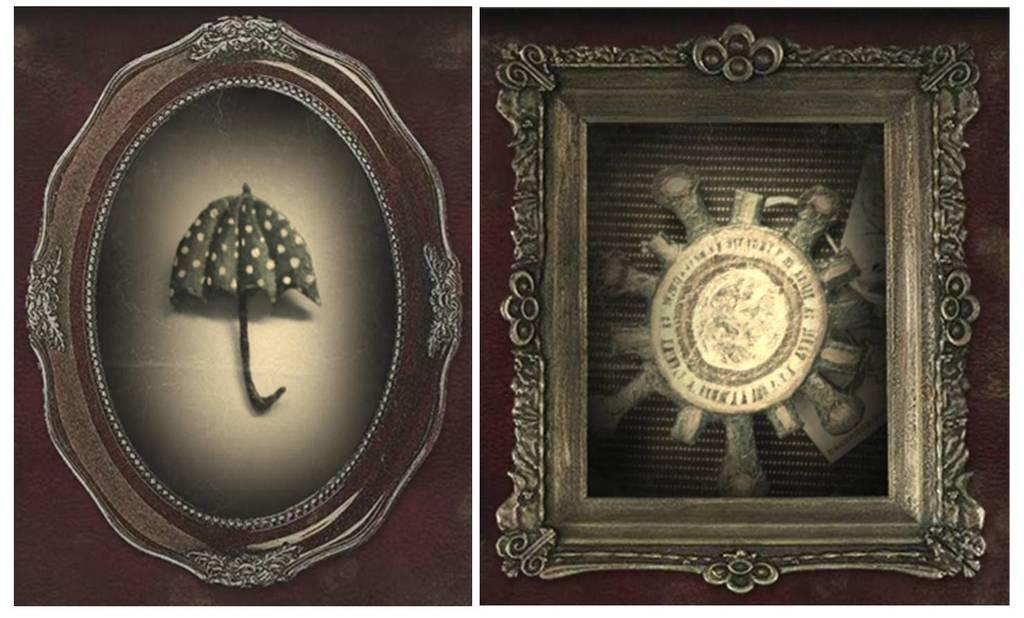What is the main feature of the image? The image contains a collage of two pictures. What can be seen in the photo frames in the image? There are photo frames visible in the image, but the contents of the frames cannot be determined from the provided facts. What type of net is being used to catch the moon in the image? There is no net or moon present in the image; it features a collage of two pictures and photo frames. 